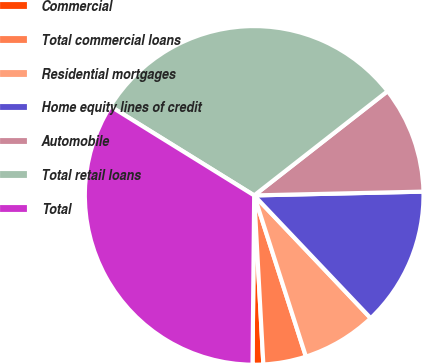<chart> <loc_0><loc_0><loc_500><loc_500><pie_chart><fcel>Commercial<fcel>Total commercial loans<fcel>Residential mortgages<fcel>Home equity lines of credit<fcel>Automobile<fcel>Total retail loans<fcel>Total<nl><fcel>1.02%<fcel>4.08%<fcel>7.14%<fcel>13.27%<fcel>10.2%<fcel>30.61%<fcel>33.67%<nl></chart> 